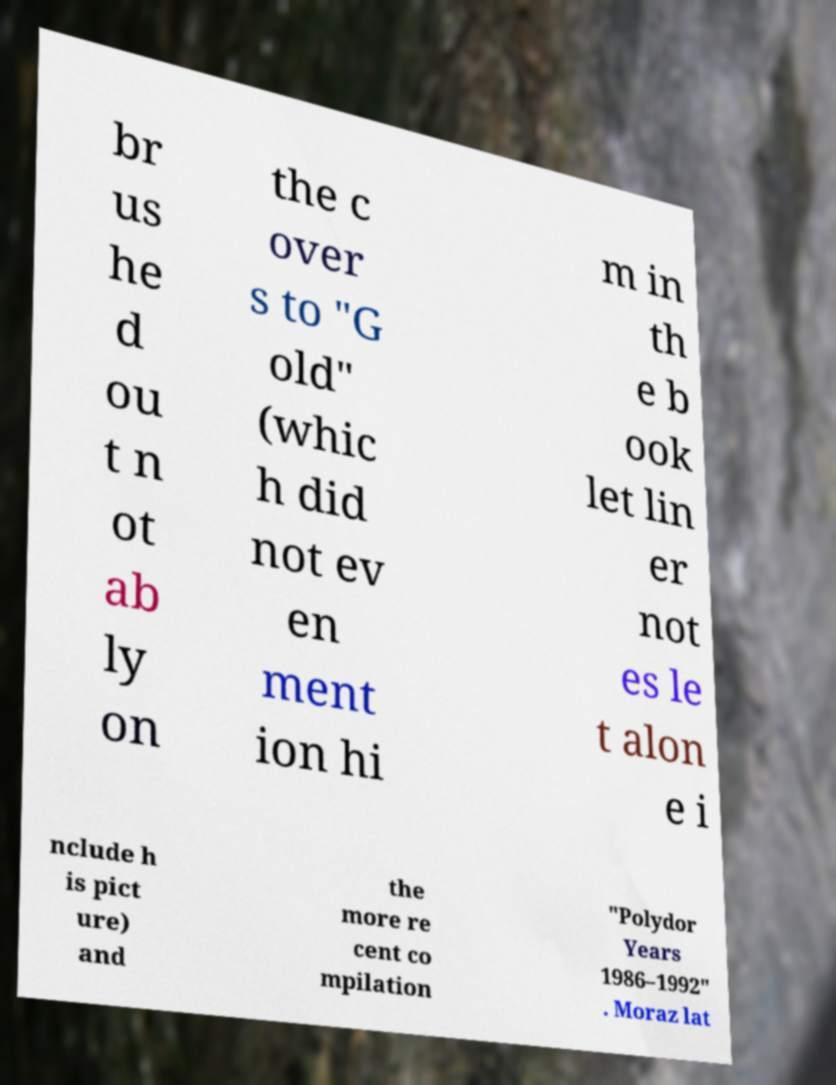For documentation purposes, I need the text within this image transcribed. Could you provide that? br us he d ou t n ot ab ly on the c over s to "G old" (whic h did not ev en ment ion hi m in th e b ook let lin er not es le t alon e i nclude h is pict ure) and the more re cent co mpilation "Polydor Years 1986–1992" . Moraz lat 